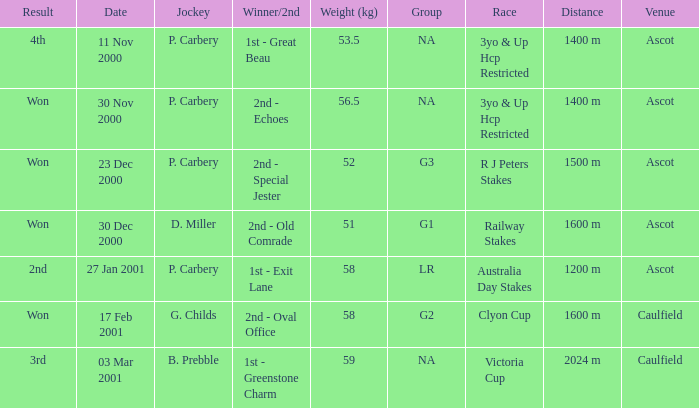What group info is available for the 56.5 kg weight? NA. Would you be able to parse every entry in this table? {'header': ['Result', 'Date', 'Jockey', 'Winner/2nd', 'Weight (kg)', 'Group', 'Race', 'Distance', 'Venue'], 'rows': [['4th', '11 Nov 2000', 'P. Carbery', '1st - Great Beau', '53.5', 'NA', '3yo & Up Hcp Restricted', '1400 m', 'Ascot'], ['Won', '30 Nov 2000', 'P. Carbery', '2nd - Echoes', '56.5', 'NA', '3yo & Up Hcp Restricted', '1400 m', 'Ascot'], ['Won', '23 Dec 2000', 'P. Carbery', '2nd - Special Jester', '52', 'G3', 'R J Peters Stakes', '1500 m', 'Ascot'], ['Won', '30 Dec 2000', 'D. Miller', '2nd - Old Comrade', '51', 'G1', 'Railway Stakes', '1600 m', 'Ascot'], ['2nd', '27 Jan 2001', 'P. Carbery', '1st - Exit Lane', '58', 'LR', 'Australia Day Stakes', '1200 m', 'Ascot'], ['Won', '17 Feb 2001', 'G. Childs', '2nd - Oval Office', '58', 'G2', 'Clyon Cup', '1600 m', 'Caulfield'], ['3rd', '03 Mar 2001', 'B. Prebble', '1st - Greenstone Charm', '59', 'NA', 'Victoria Cup', '2024 m', 'Caulfield']]} 